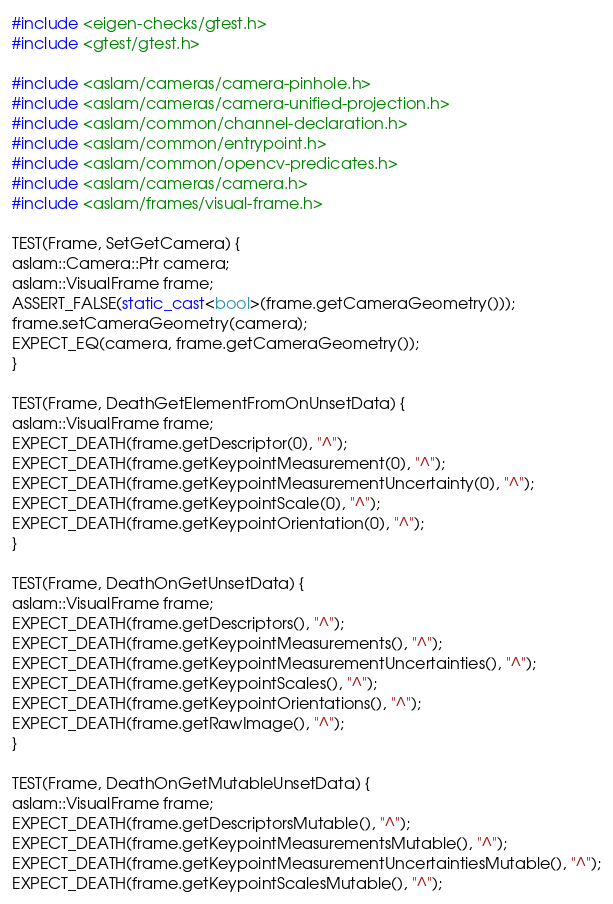<code> <loc_0><loc_0><loc_500><loc_500><_C++_>#include <eigen-checks/gtest.h>
#include <gtest/gtest.h>

#include <aslam/cameras/camera-pinhole.h>
#include <aslam/cameras/camera-unified-projection.h>
#include <aslam/common/channel-declaration.h>
#include <aslam/common/entrypoint.h>
#include <aslam/common/opencv-predicates.h>
#include <aslam/cameras/camera.h>
#include <aslam/frames/visual-frame.h>

TEST(Frame, SetGetCamera) {
aslam::Camera::Ptr camera;
aslam::VisualFrame frame;
ASSERT_FALSE(static_cast<bool>(frame.getCameraGeometry()));
frame.setCameraGeometry(camera);
EXPECT_EQ(camera, frame.getCameraGeometry());
}

TEST(Frame, DeathGetElementFromOnUnsetData) {
aslam::VisualFrame frame;
EXPECT_DEATH(frame.getDescriptor(0), "^");
EXPECT_DEATH(frame.getKeypointMeasurement(0), "^");
EXPECT_DEATH(frame.getKeypointMeasurementUncertainty(0), "^");
EXPECT_DEATH(frame.getKeypointScale(0), "^");
EXPECT_DEATH(frame.getKeypointOrientation(0), "^");
}

TEST(Frame, DeathOnGetUnsetData) {
aslam::VisualFrame frame;
EXPECT_DEATH(frame.getDescriptors(), "^");
EXPECT_DEATH(frame.getKeypointMeasurements(), "^");
EXPECT_DEATH(frame.getKeypointMeasurementUncertainties(), "^");
EXPECT_DEATH(frame.getKeypointScales(), "^");
EXPECT_DEATH(frame.getKeypointOrientations(), "^");
EXPECT_DEATH(frame.getRawImage(), "^");
}

TEST(Frame, DeathOnGetMutableUnsetData) {
aslam::VisualFrame frame;
EXPECT_DEATH(frame.getDescriptorsMutable(), "^");
EXPECT_DEATH(frame.getKeypointMeasurementsMutable(), "^");
EXPECT_DEATH(frame.getKeypointMeasurementUncertaintiesMutable(), "^");
EXPECT_DEATH(frame.getKeypointScalesMutable(), "^");</code> 